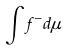Convert formula to latex. <formula><loc_0><loc_0><loc_500><loc_500>\int f ^ { - } d \mu</formula> 